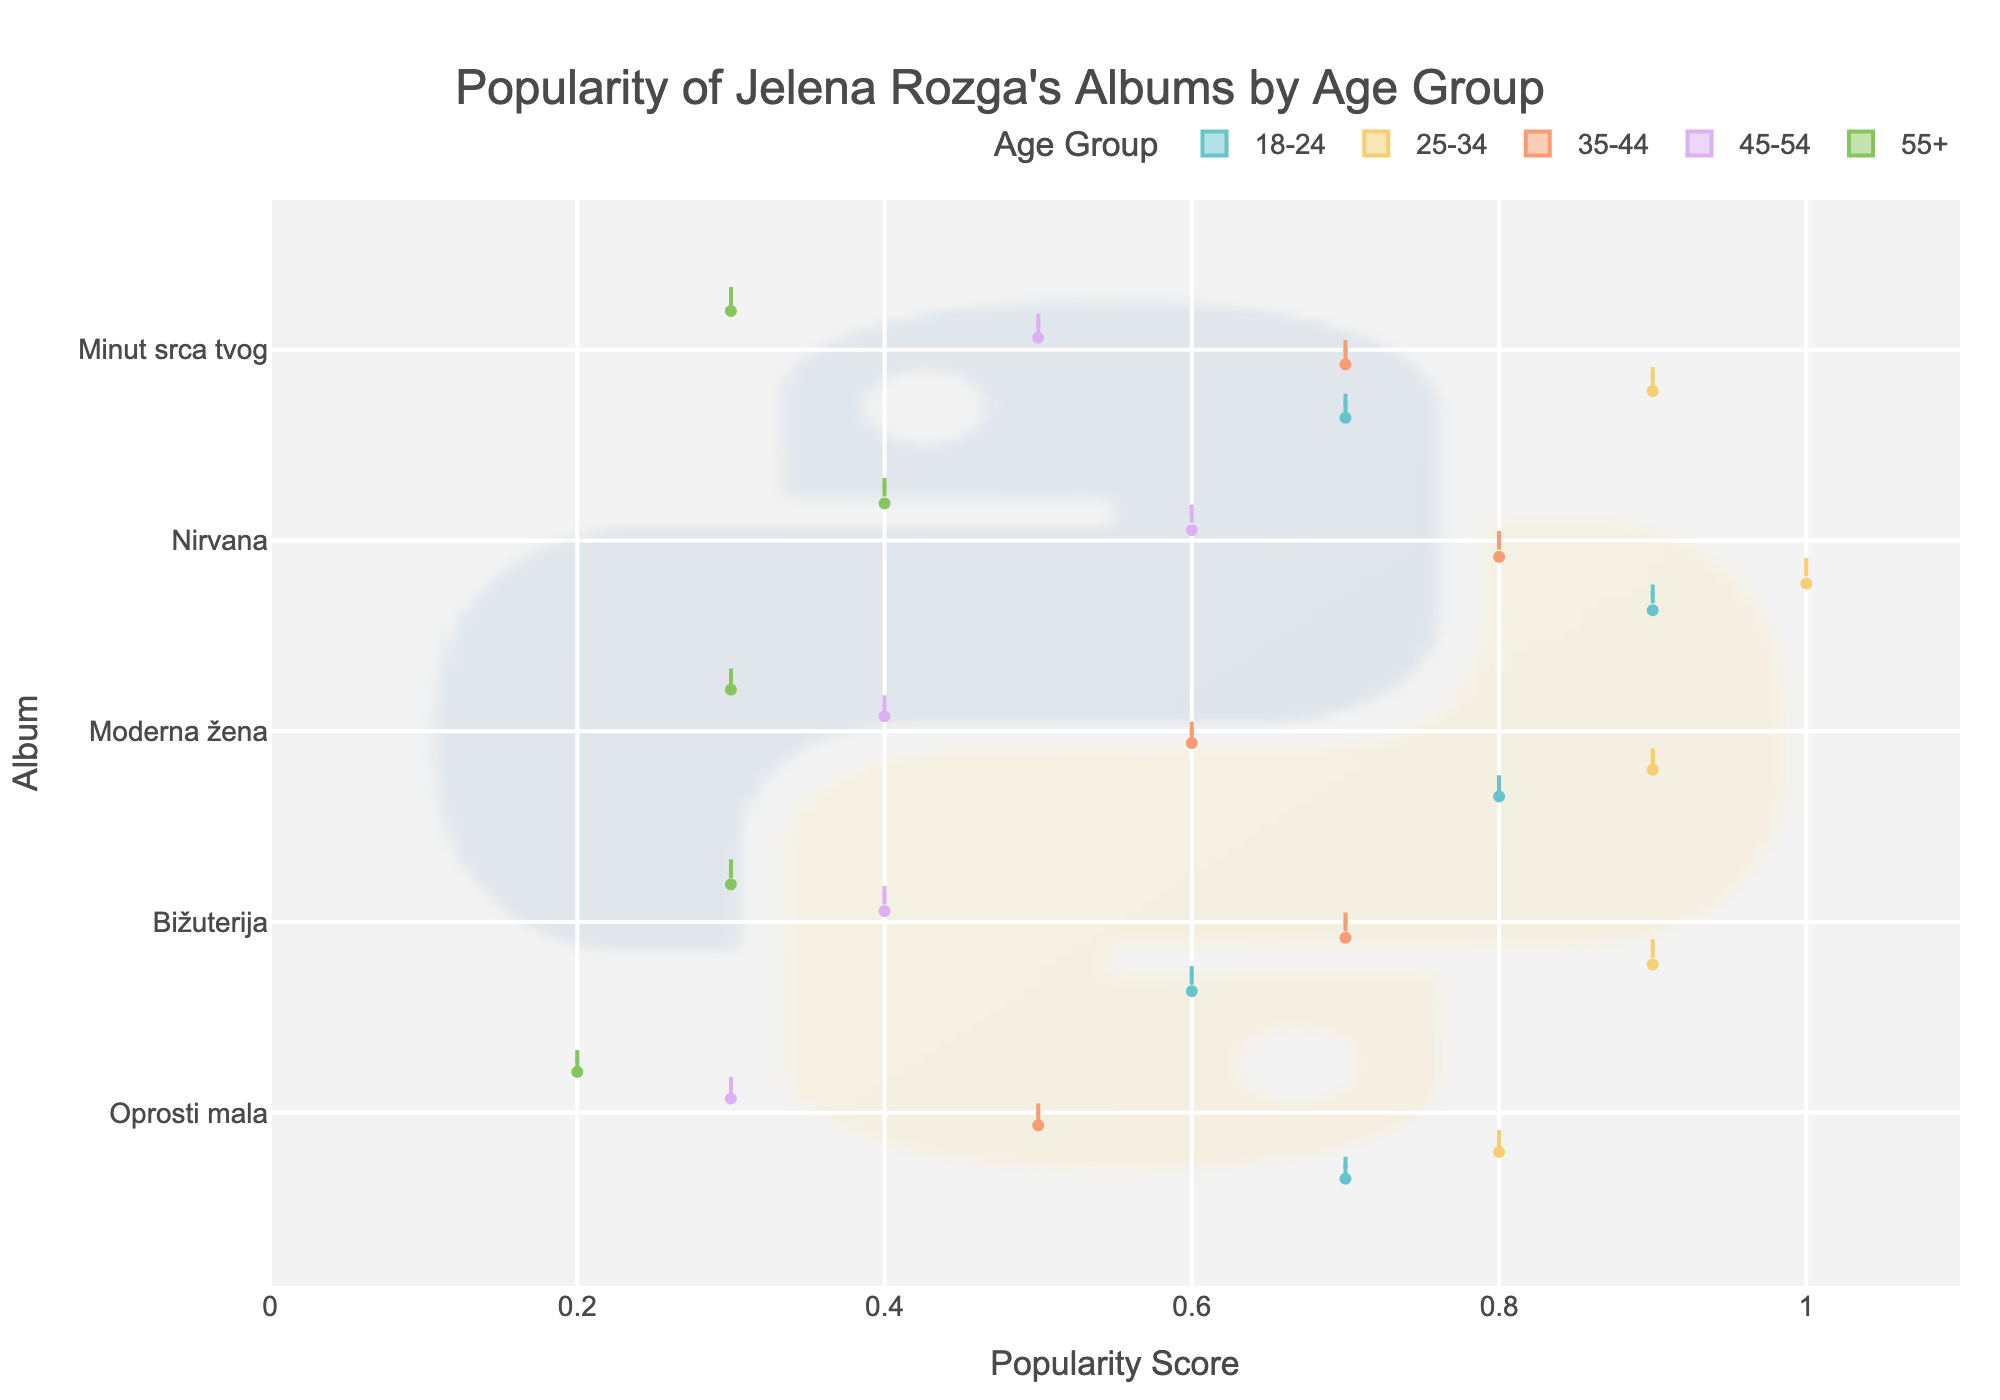What is the title of the figure? The title of the figure is located at the top and it provides a concise overview of what the chart represents. By reading directly from the figure, the title indicates the main focus of the chart.
Answer: Popularity of Jelena Rozga's Albums by Age Group Which album has the highest popularity score among the age group 25-34? To find the highest popularity score for the age group 25-34, look at the colored distributions corresponding to this age group in each album's section. Identify which album has the maximum value on the popularity axis.
Answer: Nirvana How does the popularity of "Oprosti mala" vary across different age groups? Check the spread and distribution of the violin plots for "Oprosti mala" for each age group. Observe the peak values to see how popularity changes across age groups.
Answer: Popularity decreases with age Which album shows the most consistent popularity across all age groups? Consistency can be inferred by examining the spread and overlap of the distributions across different age groups for each album. An album with narrow, less spread-out violin plots indicates more consistent popularity.
Answer: Bižuterija What is the average popularity score of "Moderna žena" across all age groups? First, list the popularity scores for "Moderna žena" across all age groups: 0.8, 0.9, 0.6, 0.4, 0.3. Sum these values (3.0) and divide by the number of age groups (5).
Answer: 0.6 Which age group shows the highest popularity for the album "Minut srca tvog"? Identify the violin plot corresponding to the album "Minut srca tvog" and look for the age group distribution that reaches the highest value on the popularity axis.
Answer: 25-34 Compare the popularity of "Nirvana" and "Moderna žena" for the age group 18-24. Which is more popular? Examine the colored distributions for the age group 18-24 for each album. Find the highest point in both distributions and compare their values.
Answer: Nirvana Which album appears to be least popular among the age group 55+? Look at the violin plots for the age group 55+ across all albums and find the one with the lowest peak value on the popularity axis.
Answer: Oprosti mala Is there any album where the popularity score for the age group 35-44 is higher than both 18-24 and 25-34? Compare the popularity scores of age group 35-44 with 18-24 and 25-34 for all albums. Specifically, check if any album's score for 35-44 exceeds both of the other age groups.
Answer: No What is the range of the popularity scores for the album "Bižuterija" across all age groups? Identify the minimum and maximum popularity scores for "Bižuterija" across all age groups, then calculate the range by subtracting the minimum score from the maximum score.
Answer: 0.6 